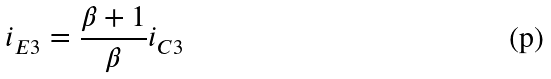Convert formula to latex. <formula><loc_0><loc_0><loc_500><loc_500>i _ { E 3 } = \frac { \beta + 1 } { \beta } i _ { C 3 }</formula> 